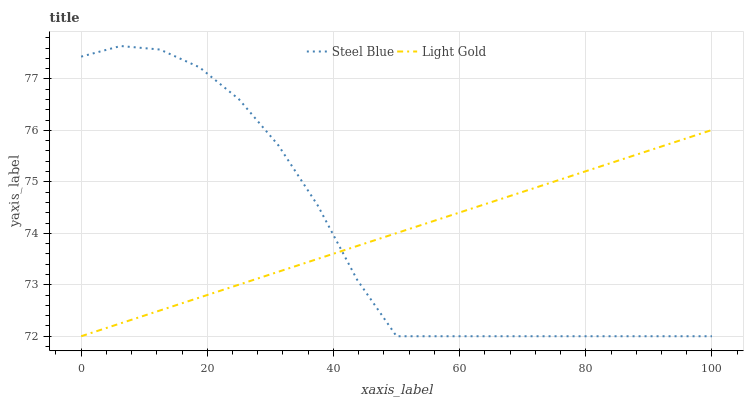Does Steel Blue have the minimum area under the curve?
Answer yes or no. Yes. Does Light Gold have the maximum area under the curve?
Answer yes or no. Yes. Does Steel Blue have the maximum area under the curve?
Answer yes or no. No. Is Light Gold the smoothest?
Answer yes or no. Yes. Is Steel Blue the roughest?
Answer yes or no. Yes. Is Steel Blue the smoothest?
Answer yes or no. No. Does Light Gold have the lowest value?
Answer yes or no. Yes. Does Steel Blue have the highest value?
Answer yes or no. Yes. Does Light Gold intersect Steel Blue?
Answer yes or no. Yes. Is Light Gold less than Steel Blue?
Answer yes or no. No. Is Light Gold greater than Steel Blue?
Answer yes or no. No. 